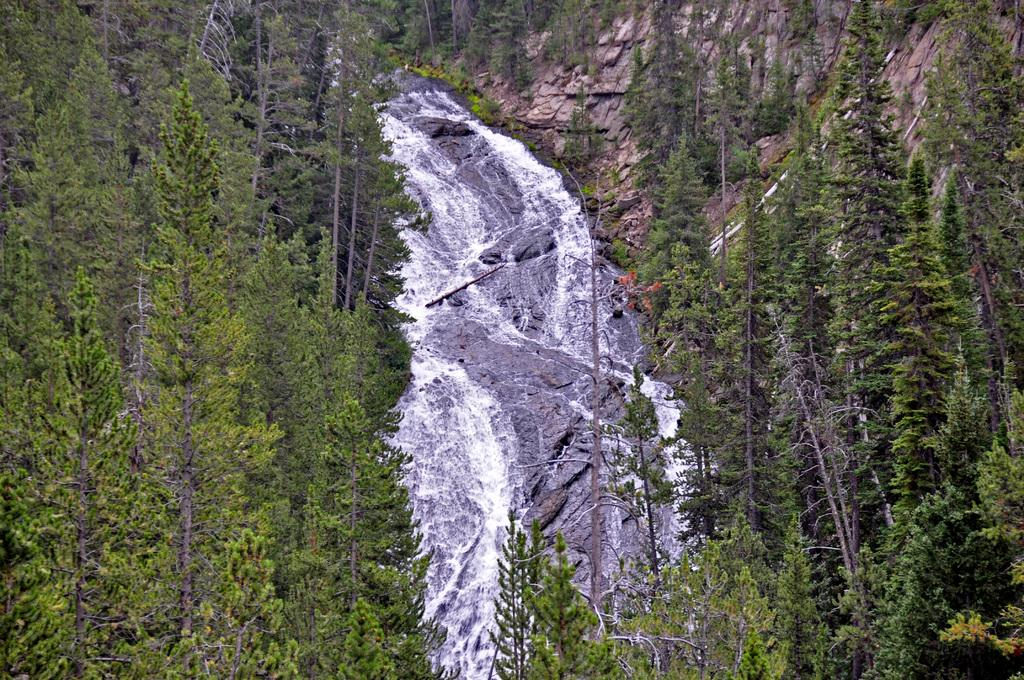Where was the picture taken? The picture was clicked outside the city. What is the main subject in the center of the image? There are rocks in the center of the image. What is the running water in the image? There is running water in the image. What type of natural environment is visible in the image? There are many trees visible in the image. What type of birthday decoration can be seen hanging from the trees in the image? There is no mention of a birthday or any decorations in the image; it features rocks, running water, and trees. Can you see a frog sitting on one of the rocks in the image? There is no frog visible in the image; it only shows rocks, running water, and trees. 